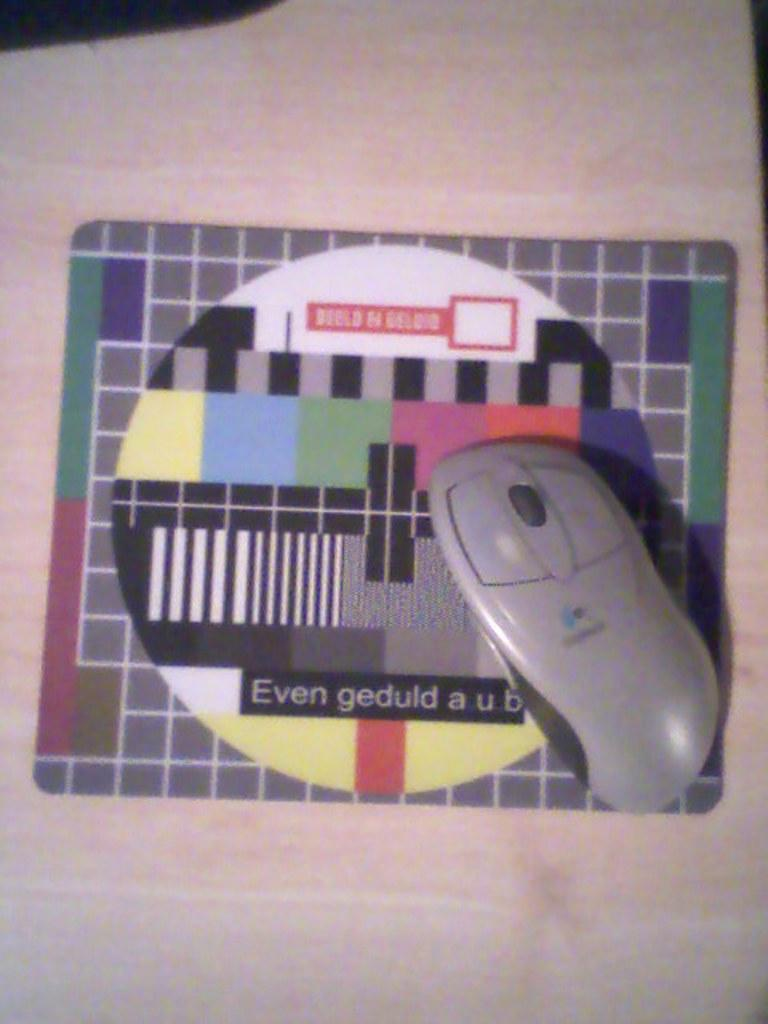What type of animal is in the image? There is a mouse in the image. Where is the mouse located? The mouse is on a mouse pad. What color is the magic spot on the mouse in the image? There is no mention of a magic spot or any color associated with it in the image. 